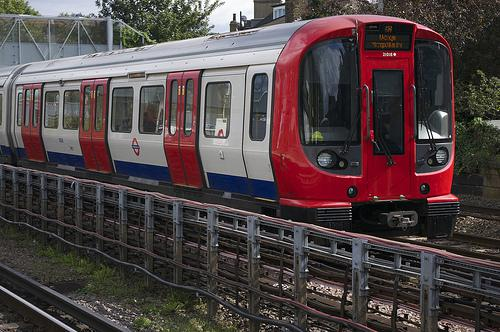Question: where was this photo taken?
Choices:
A. Near a bus stop.
B. Near a taxi stand.
C. Near an airport.
D. Near a train track.
Answer with the letter. Answer: D Question: what color are the train doors?
Choices:
A. Red.
B. Grey.
C. Black.
D. Brown.
Answer with the letter. Answer: A Question: what shape are the train's non-door windows?
Choices:
A. Circular.
B. Square.
C. Rectangular.
D. Oval.
Answer with the letter. Answer: B Question: what color is the grass?
Choices:
A. White.
B. Green.
C. Yellow.
D. Brown.
Answer with the letter. Answer: B Question: what is surrounding the train tracks?
Choices:
A. Rocks.
B. Shrubs.
C. Vegetation.
D. Trees.
Answer with the letter. Answer: C 